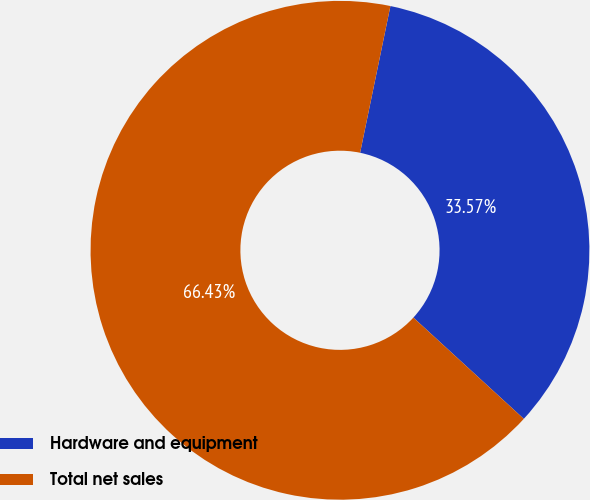Convert chart. <chart><loc_0><loc_0><loc_500><loc_500><pie_chart><fcel>Hardware and equipment<fcel>Total net sales<nl><fcel>33.57%<fcel>66.43%<nl></chart> 